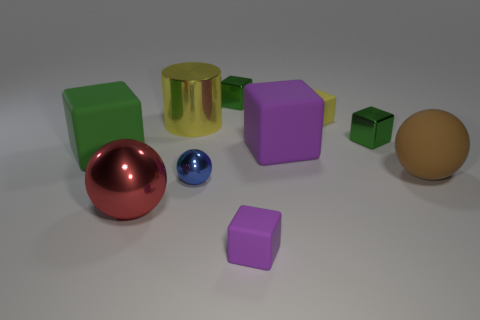Subtract all green blocks. How many were subtracted if there are1green blocks left? 2 Subtract all purple cylinders. How many purple blocks are left? 2 Subtract all big spheres. How many spheres are left? 1 Subtract 1 spheres. How many spheres are left? 2 Subtract all yellow blocks. How many blocks are left? 5 Subtract all spheres. How many objects are left? 7 Subtract 1 yellow blocks. How many objects are left? 9 Subtract all yellow spheres. Subtract all gray blocks. How many spheres are left? 3 Subtract all yellow matte cylinders. Subtract all tiny green shiny blocks. How many objects are left? 8 Add 2 large brown rubber balls. How many large brown rubber balls are left? 3 